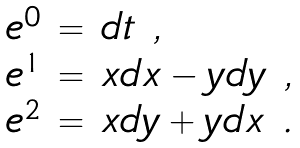Convert formula to latex. <formula><loc_0><loc_0><loc_500><loc_500>\begin{array} { r c l } e ^ { 0 } & = & d t \ , \\ e ^ { 1 } & = & x d x - y d y \ , \\ e ^ { 2 } & = & x d y + y d x \ . \end{array}</formula> 